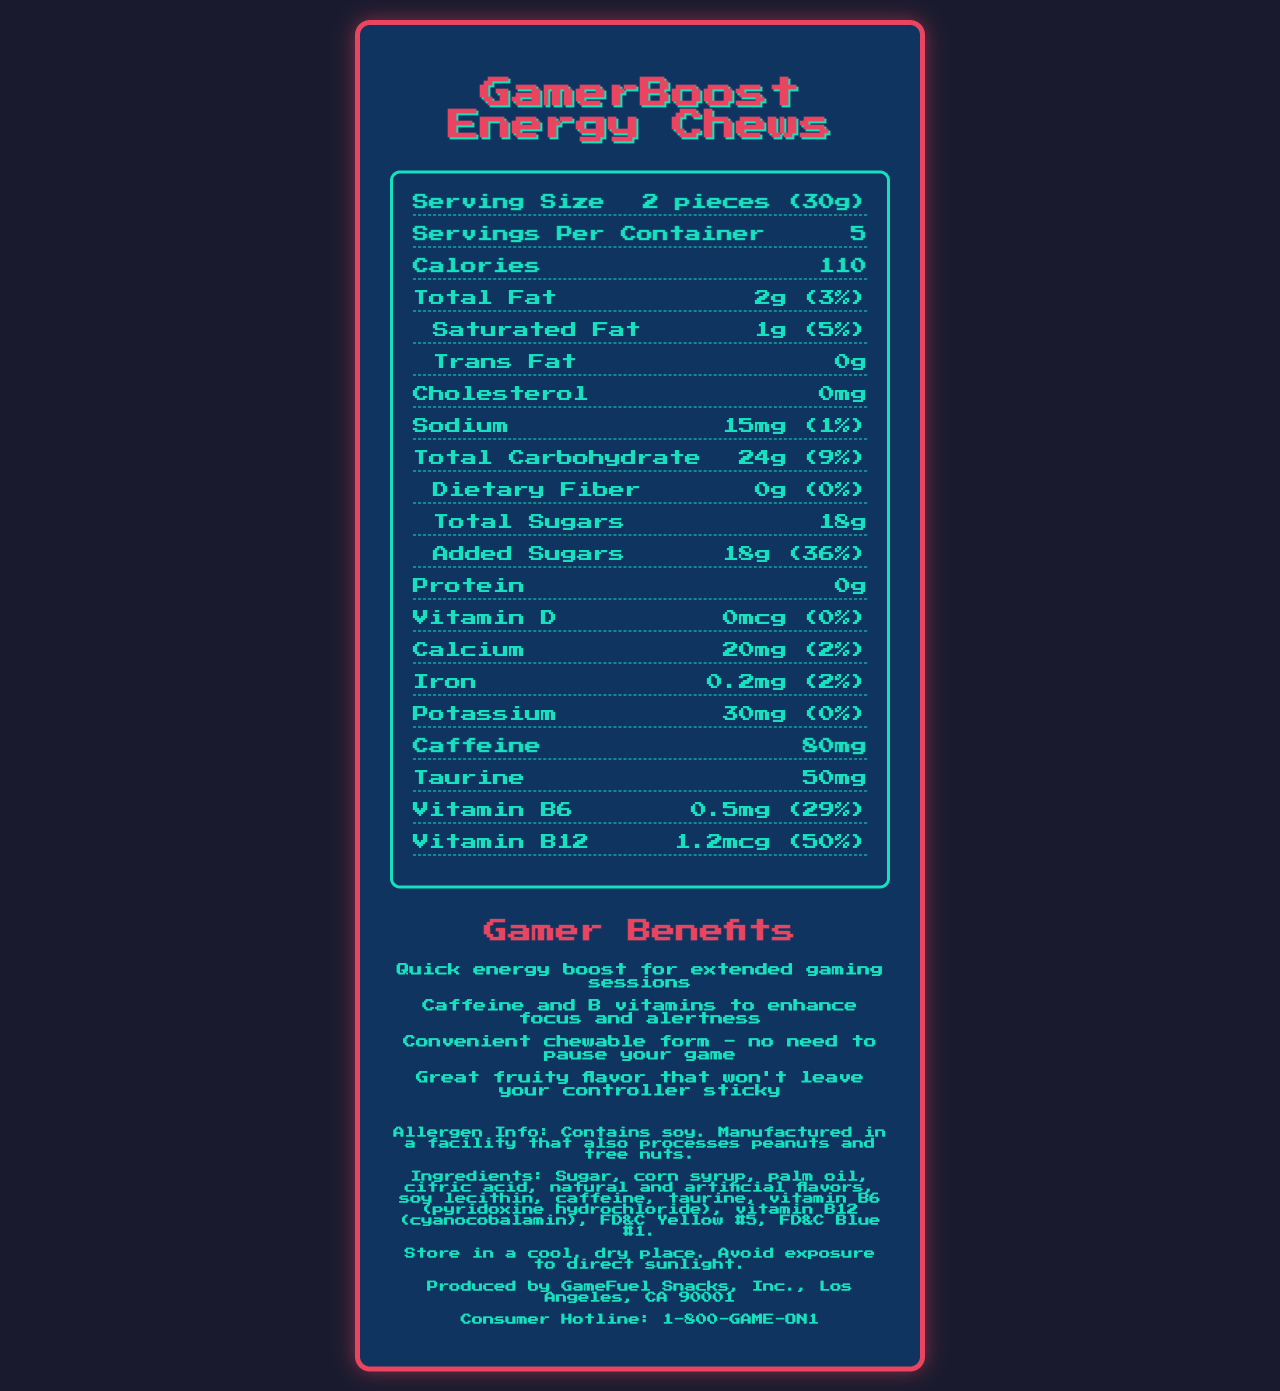what is the serving size of GamerBoost Energy Chews? The serving size is listed at the very beginning of the nutrition information as "2 pieces (30g)".
Answer: 2 pieces (30g) how many servings are in a container? The number of servings per container is directly mentioned as "5".
Answer: 5 how much caffeine is in one serving? The amount of caffeine per serving is listed in the nutrition information as "80mg".
Answer: 80mg what is the total carbohydrate content per serving? The total carbohydrate content per serving is shown in the document as "24g".
Answer: 24g what are the main vitamins included in GamerBoost Energy Chews? The vitamins included are Vitamin B6 and Vitamin B12, indicated in the nutrition facts.
Answer: Vitamin B6 and Vitamin B12 which of the following ingredients is not in GamerBoost Energy Chews? A. Sugar B. Corn Syrup C. Gluten D. Palm Oil The ingredients list does not include gluten; it includes Sugar, Corn Syrup, and Palm Oil.
Answer: C how much sodium is in a serving? A. 10mg B. 15mg C. 20mg The sodium content per serving is listed as "15mg".
Answer: B which vitamin has the highest daily value percentage? I. Vitamin B6 II. Vitamin B12 III. Vitamin D Vitamin B12 has the highest daily value percentage at "50%", compared to Vitamin B6 at "29%" and Vitamin D at "0%".
Answer: II does the product contain any allergens? The document states that the product "Contains soy" and is manufactured in a facility that processes peanuts and tree nuts.
Answer: Yes what is the main purpose of GamerBoost Energy Chews? The primary purpose as claimed is to provide a "Quick energy boost for extended gaming sessions".
Answer: Quick energy boost for extended gaming sessions summarize the nutrition and benefit information of GamerBoost Energy Chews. The summary covers the nutritional aspects and the intended benefits such as energy boost, convenience, and included vitamins.
Answer: GamerBoost Energy Chews are designed to provide a quick energy boost, especially for gamers. Each serving (2 pieces or 30g) contains 110 calories, 24g of carbohydrates (including 18g of sugars), 2g of fat, and 80mg of caffeine. Additionally, it includes vitamins B6 and B12, which enhance focus and alertness. Key features include being chewable, convenient for gamers, and containing allergen soy. what is the primary flavor type mentioned for the candy? The marketing claims highlight a "Great fruity flavor".
Answer: Fruity how should the product be stored? The document provides specific storage instructions stating to store it in a cool, dry place and avoid direct sunlight.
Answer: Store in a cool, dry place. Avoid exposure to direct sunlight. does the product contain any cholesterol? The nutrition facts list cholesterol content as "0mg".
Answer: No is the amount of trans fat present in GamerBoost Energy Chews? The document indicates that there are "0g" of trans fat.
Answer: No which company's information is provided as the manufacturer? The manufacturer is listed at the bottom of the document as "GameFuel Snacks, Inc., Los Angeles, CA 90001".
Answer: GameFuel Snacks, Inc., Los Angeles, CA 90001 how much palm oil is in the product? The document lists palm oil as an ingredient but does not specify the amount.
Answer: Not enough information what is the total fiber content per serving? The dietary fiber content per serving is listed as "0g".
Answer: 0g what phone number is provided for consumer inquiries? The consumer hotline number provided is "1-800-GAME-ON1".
Answer: 1-800-GAME-ON1 how many calories come from sugars alone in one serving? The document gives the total and added sugars but does not break down the calories specifically from sugars.
Answer: Not enough information 